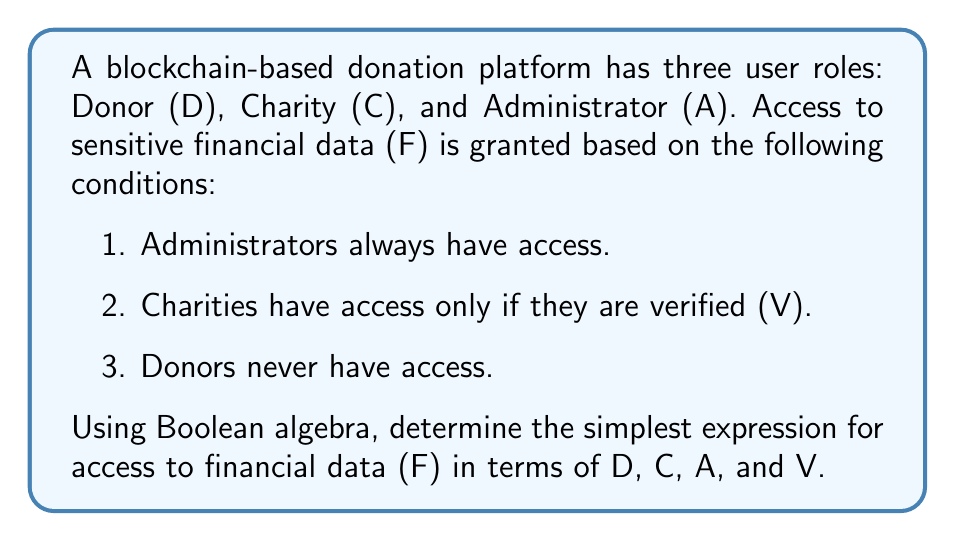Solve this math problem. Let's approach this step-by-step using Boolean algebra:

1. First, we'll express each condition as a Boolean expression:
   - Administrators always have access: $A$
   - Charities have access if verified: $C \land V$
   - Donors never have access: $\lnot D$

2. The overall expression for access to financial data (F) is the OR of these conditions:
   $$F = A \lor (C \land V) \lor (\lnot D \land C \land V)$$

3. Simplify using Boolean algebra laws:
   $$F = A \lor (C \land V)$$

   The $(\lnot D \land C \land V)$ term is redundant because it's already covered by $(C \land V)$.

4. We can't simplify further because we need to maintain the distinction between administrators (who always have access) and verified charities.

Therefore, the simplest expression for access to financial data is $A \lor (C \land V)$.
Answer: $F = A \lor (C \land V)$ 